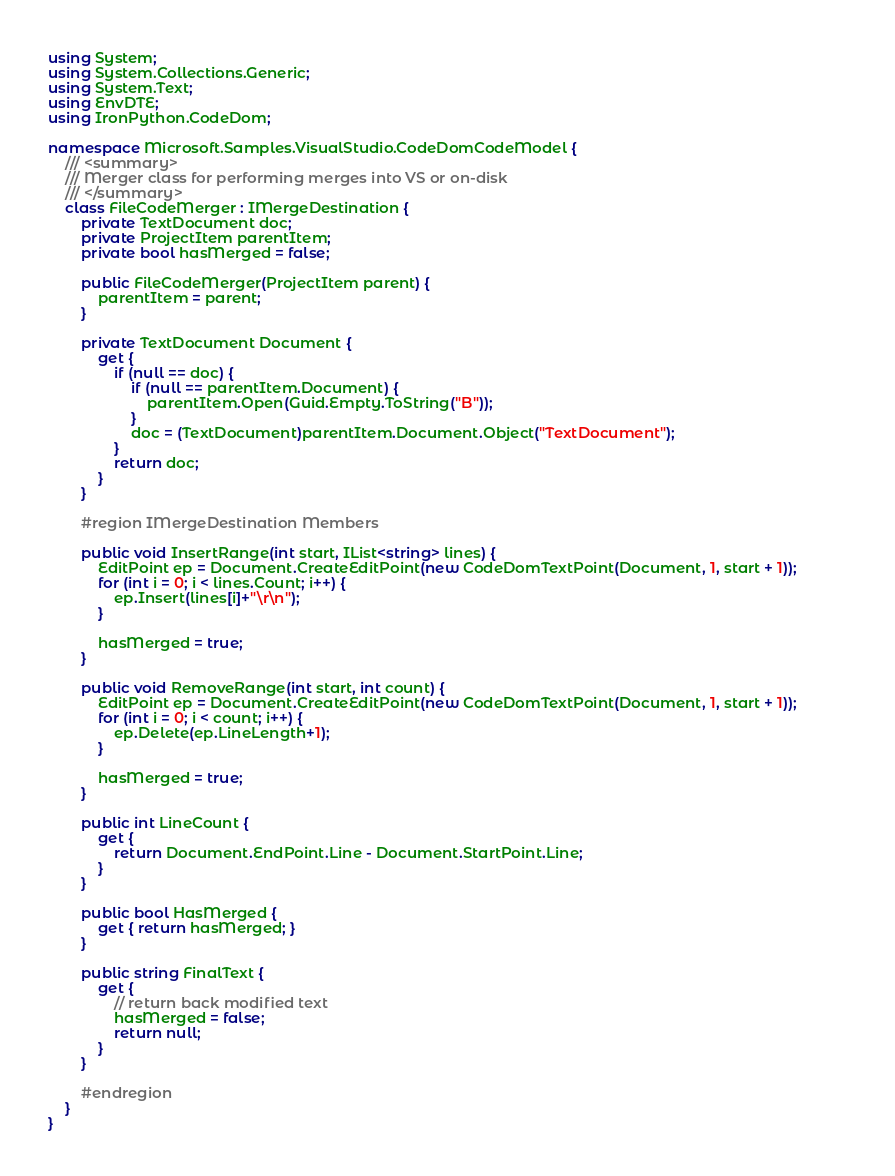Convert code to text. <code><loc_0><loc_0><loc_500><loc_500><_C#_>using System;
using System.Collections.Generic;
using System.Text;
using EnvDTE;
using IronPython.CodeDom;

namespace Microsoft.Samples.VisualStudio.CodeDomCodeModel {
    /// <summary>
    /// Merger class for performing merges into VS or on-disk
    /// </summary>
    class FileCodeMerger : IMergeDestination {
        private TextDocument doc;
        private ProjectItem parentItem;
        private bool hasMerged = false;

        public FileCodeMerger(ProjectItem parent) {
            parentItem = parent;
        }

        private TextDocument Document {
            get {
                if (null == doc) {
                    if (null == parentItem.Document) {
                        parentItem.Open(Guid.Empty.ToString("B"));
                    }
                    doc = (TextDocument)parentItem.Document.Object("TextDocument");
                }
                return doc;
            }
        }

        #region IMergeDestination Members

        public void InsertRange(int start, IList<string> lines) {
            EditPoint ep = Document.CreateEditPoint(new CodeDomTextPoint(Document, 1, start + 1));
            for (int i = 0; i < lines.Count; i++) {
                ep.Insert(lines[i]+"\r\n");
            }

            hasMerged = true;
        }

        public void RemoveRange(int start, int count) {
            EditPoint ep = Document.CreateEditPoint(new CodeDomTextPoint(Document, 1, start + 1));            
            for (int i = 0; i < count; i++) {
                ep.Delete(ep.LineLength+1);
            }

            hasMerged = true;
        }

        public int LineCount {
            get {
                return Document.EndPoint.Line - Document.StartPoint.Line;
            }
        }

        public bool HasMerged {
            get { return hasMerged; }
        }

        public string FinalText {
            get { 
                // return back modified text
                hasMerged = false;
                return null;
            }
        }

        #endregion
    }
}
</code> 